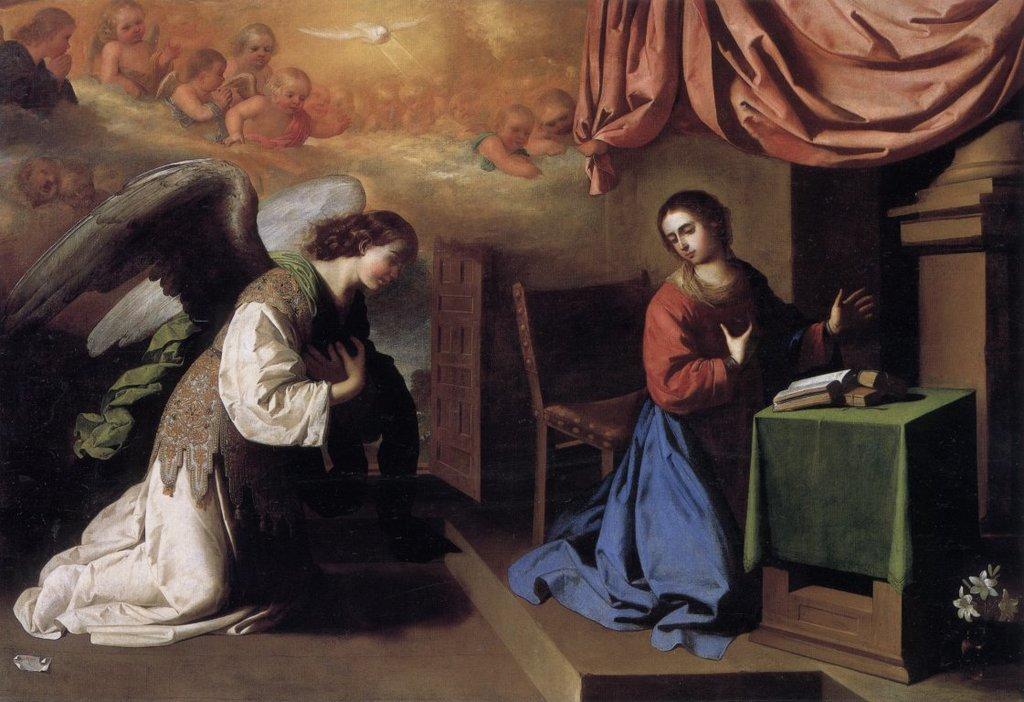Can you describe this image briefly? In this image there is a painting of two girls, one of them is wearing wings and the other one is sitting on her knees in front of the table. On the table there are few objects and there is a flower pot, behind her there is a chair. In the background there is a wall and a curtain. On the wall there are few images of babies and a bird. 